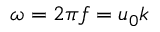<formula> <loc_0><loc_0><loc_500><loc_500>\omega = 2 \pi f = u _ { 0 } k</formula> 